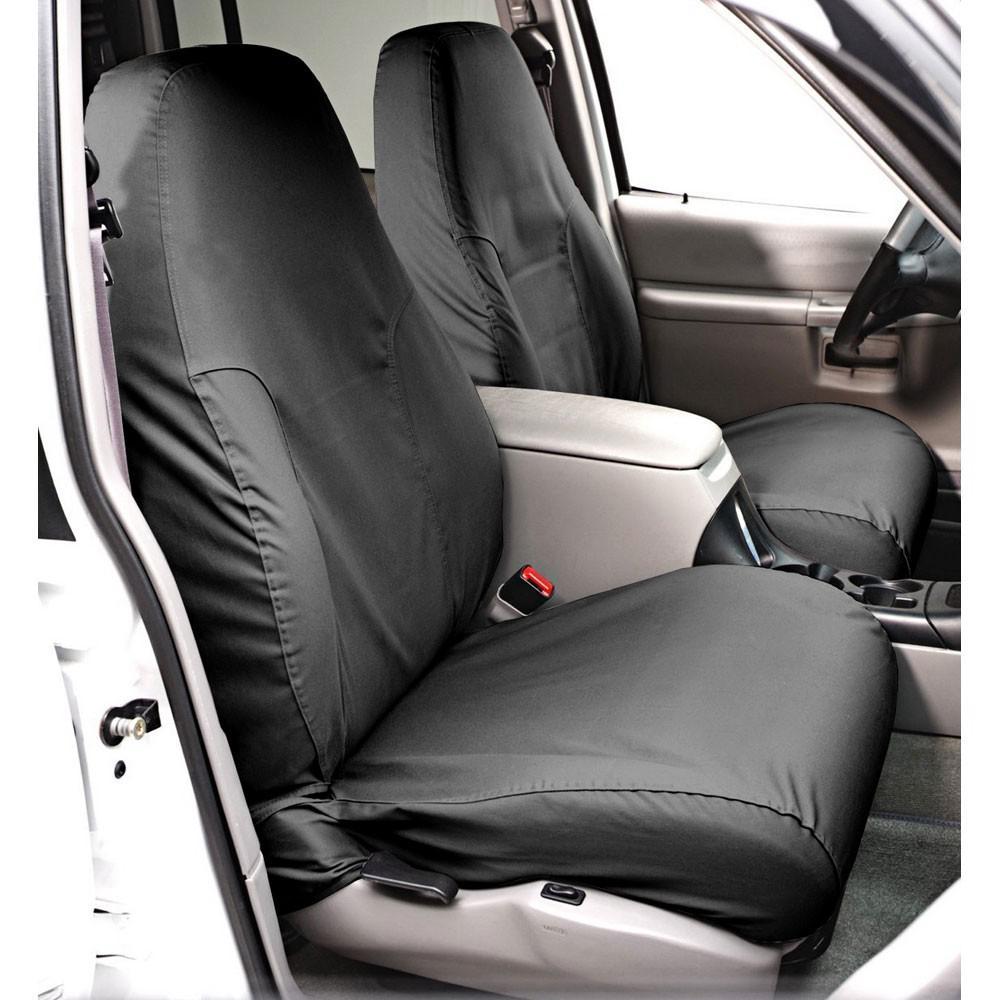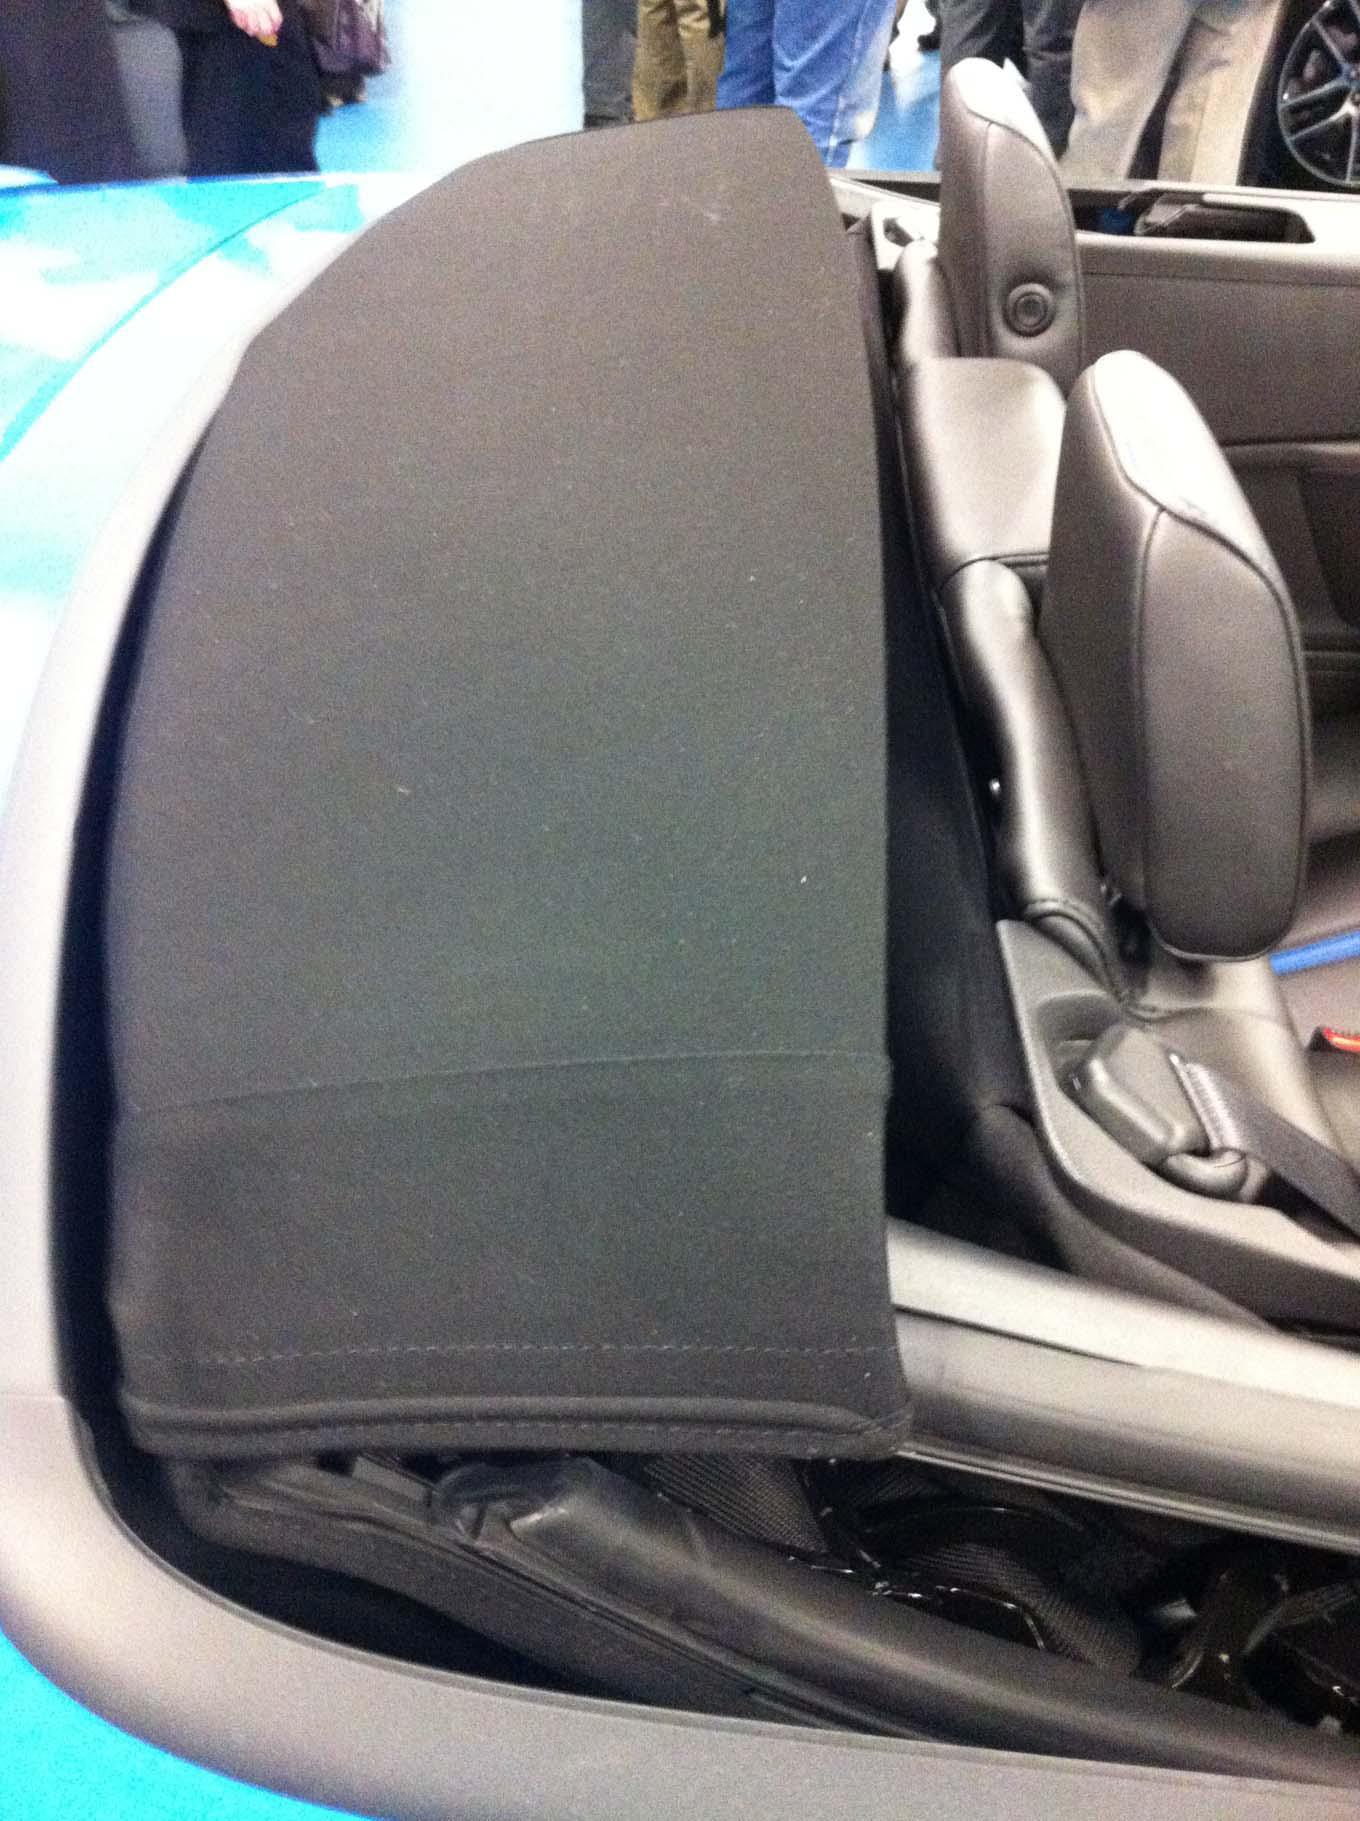The first image is the image on the left, the second image is the image on the right. Considering the images on both sides, is "One image shows white upholstered front seats and a darker steering wheel in a convertible car's interior, and the other image shows the folded soft top at the rear of the vehicle." valid? Answer yes or no. No. 